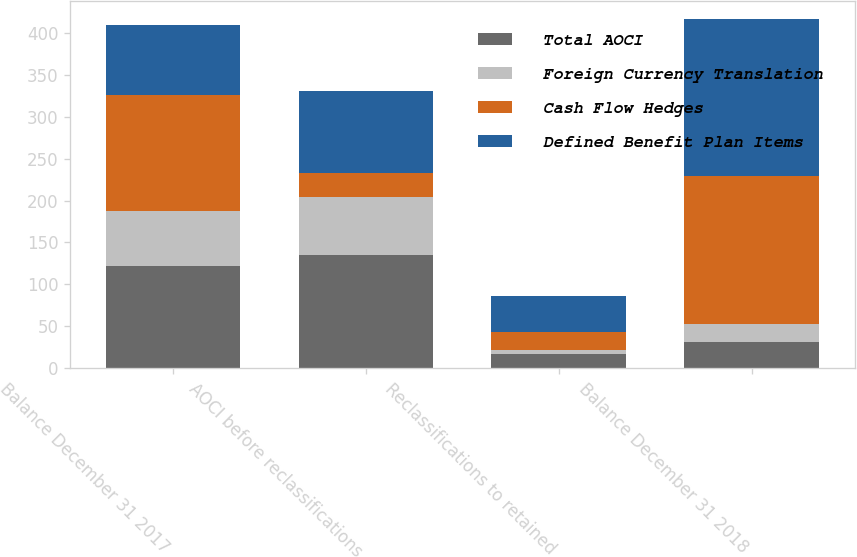Convert chart to OTSL. <chart><loc_0><loc_0><loc_500><loc_500><stacked_bar_chart><ecel><fcel>Balance December 31 2017<fcel>AOCI before reclassifications<fcel>Reclassifications to retained<fcel>Balance December 31 2018<nl><fcel>Total AOCI<fcel>121.5<fcel>135.4<fcel>17.4<fcel>31.3<nl><fcel>Foreign Currency Translation<fcel>66.5<fcel>68.2<fcel>4.4<fcel>20.9<nl><fcel>Cash Flow Hedges<fcel>138.2<fcel>29.7<fcel>21.1<fcel>177<nl><fcel>Defined Benefit Plan Items<fcel>83.2<fcel>96.9<fcel>42.9<fcel>187.4<nl></chart> 